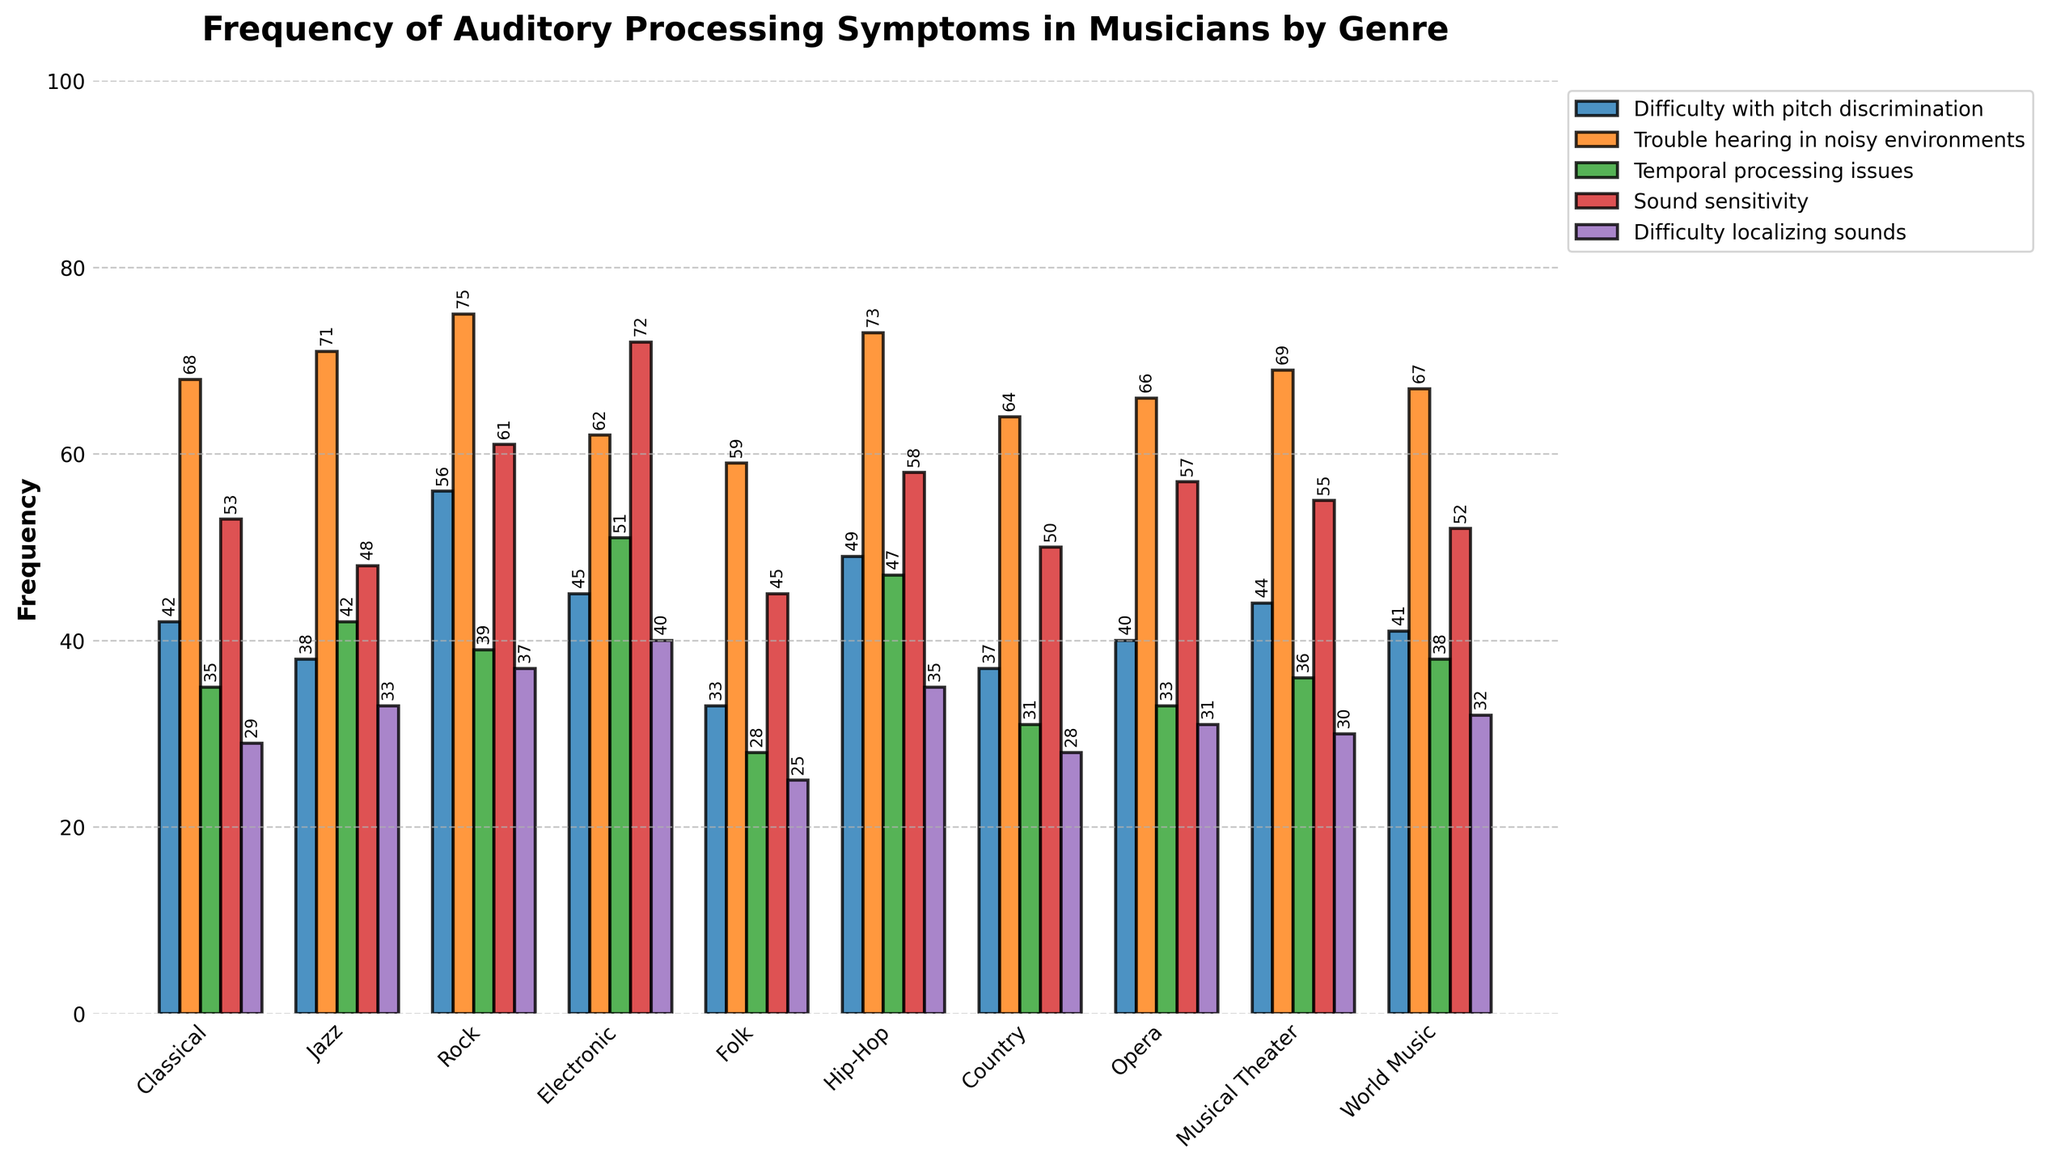What genre has the highest frequency of trouble hearing in noisy environments? Look at the bars representing "Trouble hearing in noisy environments" across all genres. The highest bar corresponds to the Rock genre with a frequency of 75.
Answer: Rock Which genre reports the least difficulty with pitch discrimination? Check the bars for "Difficulty with pitch discrimination" and find the shortest one. The Folk genre has the lowest bar with a frequency of 33.
Answer: Folk What's the difference between the highest and lowest frequencies of temporal processing issues? Identify the highest and lowest bars for "Temporal processing issues". The highest is Electronic at 51, and the lowest is Folk at 28. The difference is 51 - 28 = 23.
Answer: 23 How many genres report more than 50 instances of sound sensitivity? Count the number of genres where the bar for "Sound sensitivity" exceeds the 50 mark. They are Classical, Rock, Electronic, Hip-Hop, and Musical Theater, totaling 5 genres.
Answer: 5 Are there any genres where difficulty localizing sounds is greater than both sound sensitivity and temporal processing issues? Compare the bars for "Difficulty localizing sounds" with those for "Sound sensitivity" and "Temporal processing issues" within each genre. No genre has a higher frequency of difficulty localizing sounds compared to both the other symptoms.
Answer: No What is the average frequency of all reported symptoms in the Jazz genre? Sum the frequencies of all symptoms for Jazz and divide by the number of symptoms: (38+71+42+48+33) / 5 = 46.4.
Answer: 46.4 Which genre has the closest frequency values for difficulty with pitch discrimination and difficulty localizing sounds? Compare the frequencies of "Difficulty with pitch discrimination" and "Difficulty localizing sounds" for each genre. The closest values are found in Country, with 37 and 28, respectively, a difference of 9.
Answer: Country If you sum the frequency of difficulty with pitch discrimination and sound sensitivity for Rock, what is the result? Add the frequencies for "Difficulty with pitch discrimination" (56) and "Sound sensitivity" (61) in Rock. 56 + 61 = 117.
Answer: 117 Which genre has the highest variety in the frequencies reported for the various symptoms? Calculate the range (max - min) for each genre and identify the genre with the highest range. For Electronic: 72 (max) - 40 (min) = 32.
Answer: Electronic Is there any genre where the frequency of trouble hearing in noisy environments is above 70 for more than three symptoms? Check the frequency for "Trouble hearing in noisy environments" and count the number of symptoms exceeding 70 in each genre. No genre has more than three symptoms above 70.
Answer: No 